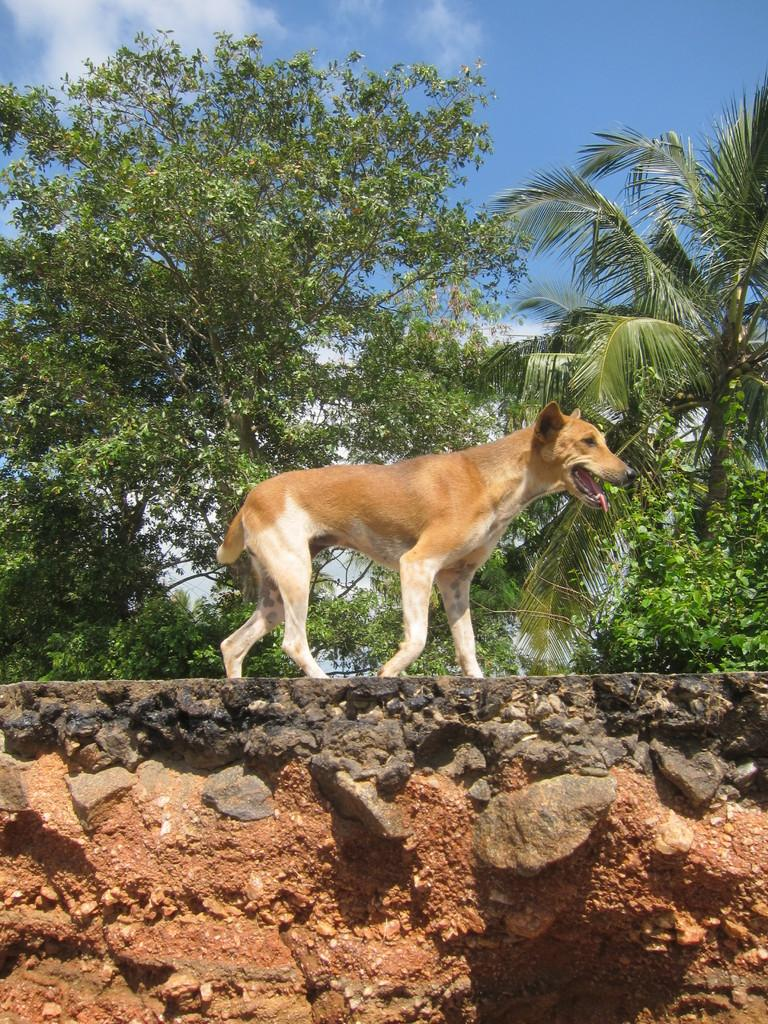What type of animal is in the image? There is a dog in the image. What is located behind the dog? Trees are present behind the dog. How would you describe the sky in the image? The sky is blue with clouds. What type of terrain is visible at the bottom of the image? Rocks and sand are visible at the bottom of the image. What color is the shirt worn by the crow in the image? There is no crow present in the image, and therefore no shirt to describe. 